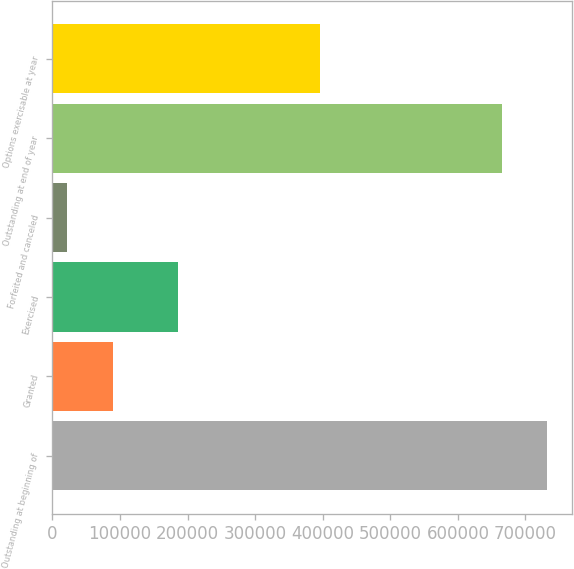Convert chart. <chart><loc_0><loc_0><loc_500><loc_500><bar_chart><fcel>Outstanding at beginning of<fcel>Granted<fcel>Exercised<fcel>Forfeited and canceled<fcel>Outstanding at end of year<fcel>Options exercisable at year<nl><fcel>732174<fcel>88988.8<fcel>185387<fcel>21600<fcel>664785<fcel>395986<nl></chart> 